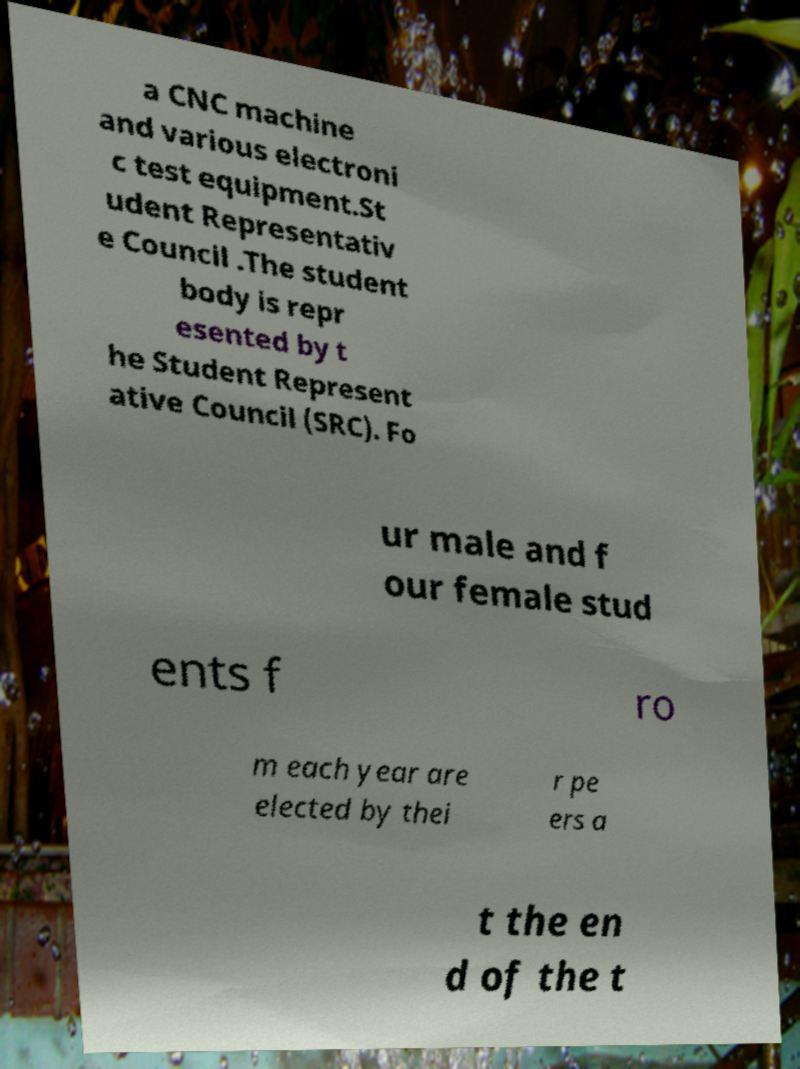Please identify and transcribe the text found in this image. a CNC machine and various electroni c test equipment.St udent Representativ e Council .The student body is repr esented by t he Student Represent ative Council (SRC). Fo ur male and f our female stud ents f ro m each year are elected by thei r pe ers a t the en d of the t 